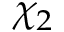Convert formula to latex. <formula><loc_0><loc_0><loc_500><loc_500>\chi _ { 2 }</formula> 